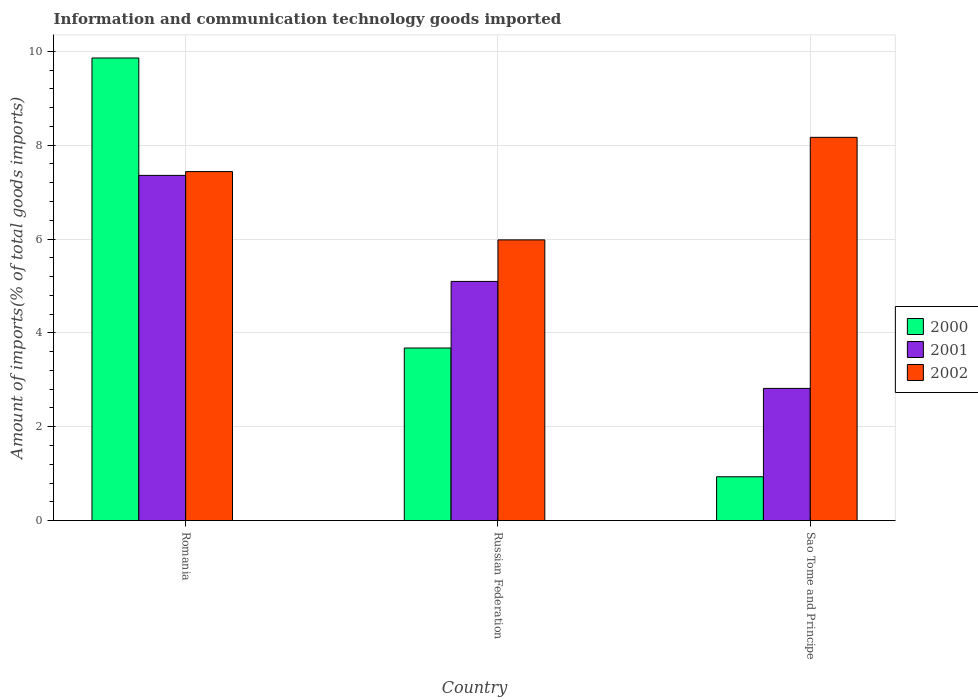How many different coloured bars are there?
Offer a terse response. 3. Are the number of bars per tick equal to the number of legend labels?
Your answer should be compact. Yes. Are the number of bars on each tick of the X-axis equal?
Your response must be concise. Yes. What is the label of the 1st group of bars from the left?
Provide a short and direct response. Romania. What is the amount of goods imported in 2002 in Sao Tome and Principe?
Offer a terse response. 8.17. Across all countries, what is the maximum amount of goods imported in 2000?
Provide a succinct answer. 9.86. Across all countries, what is the minimum amount of goods imported in 2001?
Your response must be concise. 2.82. In which country was the amount of goods imported in 2001 maximum?
Your answer should be compact. Romania. In which country was the amount of goods imported in 2000 minimum?
Give a very brief answer. Sao Tome and Principe. What is the total amount of goods imported in 2002 in the graph?
Offer a terse response. 21.59. What is the difference between the amount of goods imported in 2000 in Romania and that in Russian Federation?
Give a very brief answer. 6.18. What is the difference between the amount of goods imported in 2002 in Sao Tome and Principe and the amount of goods imported in 2000 in Romania?
Give a very brief answer. -1.69. What is the average amount of goods imported in 2000 per country?
Provide a succinct answer. 4.82. What is the difference between the amount of goods imported of/in 2000 and amount of goods imported of/in 2002 in Russian Federation?
Make the answer very short. -2.3. In how many countries, is the amount of goods imported in 2000 greater than 7.6 %?
Offer a terse response. 1. What is the ratio of the amount of goods imported in 2000 in Romania to that in Russian Federation?
Offer a terse response. 2.68. Is the difference between the amount of goods imported in 2000 in Romania and Russian Federation greater than the difference between the amount of goods imported in 2002 in Romania and Russian Federation?
Ensure brevity in your answer.  Yes. What is the difference between the highest and the second highest amount of goods imported in 2001?
Provide a short and direct response. -2.28. What is the difference between the highest and the lowest amount of goods imported in 2002?
Ensure brevity in your answer.  2.19. How many bars are there?
Ensure brevity in your answer.  9. Are all the bars in the graph horizontal?
Offer a terse response. No. How many countries are there in the graph?
Keep it short and to the point. 3. What is the difference between two consecutive major ticks on the Y-axis?
Your answer should be very brief. 2. Are the values on the major ticks of Y-axis written in scientific E-notation?
Make the answer very short. No. Where does the legend appear in the graph?
Ensure brevity in your answer.  Center right. How many legend labels are there?
Ensure brevity in your answer.  3. What is the title of the graph?
Offer a very short reply. Information and communication technology goods imported. Does "1987" appear as one of the legend labels in the graph?
Your response must be concise. No. What is the label or title of the X-axis?
Your answer should be compact. Country. What is the label or title of the Y-axis?
Provide a short and direct response. Amount of imports(% of total goods imports). What is the Amount of imports(% of total goods imports) in 2000 in Romania?
Ensure brevity in your answer.  9.86. What is the Amount of imports(% of total goods imports) in 2001 in Romania?
Your answer should be compact. 7.36. What is the Amount of imports(% of total goods imports) of 2002 in Romania?
Offer a very short reply. 7.44. What is the Amount of imports(% of total goods imports) of 2000 in Russian Federation?
Make the answer very short. 3.68. What is the Amount of imports(% of total goods imports) in 2001 in Russian Federation?
Provide a succinct answer. 5.1. What is the Amount of imports(% of total goods imports) of 2002 in Russian Federation?
Provide a short and direct response. 5.98. What is the Amount of imports(% of total goods imports) in 2000 in Sao Tome and Principe?
Offer a terse response. 0.93. What is the Amount of imports(% of total goods imports) in 2001 in Sao Tome and Principe?
Your response must be concise. 2.82. What is the Amount of imports(% of total goods imports) in 2002 in Sao Tome and Principe?
Your answer should be very brief. 8.17. Across all countries, what is the maximum Amount of imports(% of total goods imports) of 2000?
Offer a very short reply. 9.86. Across all countries, what is the maximum Amount of imports(% of total goods imports) of 2001?
Your answer should be compact. 7.36. Across all countries, what is the maximum Amount of imports(% of total goods imports) in 2002?
Offer a terse response. 8.17. Across all countries, what is the minimum Amount of imports(% of total goods imports) in 2000?
Your answer should be compact. 0.93. Across all countries, what is the minimum Amount of imports(% of total goods imports) of 2001?
Your answer should be very brief. 2.82. Across all countries, what is the minimum Amount of imports(% of total goods imports) in 2002?
Give a very brief answer. 5.98. What is the total Amount of imports(% of total goods imports) in 2000 in the graph?
Provide a short and direct response. 14.47. What is the total Amount of imports(% of total goods imports) in 2001 in the graph?
Ensure brevity in your answer.  15.27. What is the total Amount of imports(% of total goods imports) of 2002 in the graph?
Your response must be concise. 21.59. What is the difference between the Amount of imports(% of total goods imports) in 2000 in Romania and that in Russian Federation?
Ensure brevity in your answer.  6.18. What is the difference between the Amount of imports(% of total goods imports) in 2001 in Romania and that in Russian Federation?
Your response must be concise. 2.26. What is the difference between the Amount of imports(% of total goods imports) of 2002 in Romania and that in Russian Federation?
Keep it short and to the point. 1.46. What is the difference between the Amount of imports(% of total goods imports) in 2000 in Romania and that in Sao Tome and Principe?
Provide a succinct answer. 8.92. What is the difference between the Amount of imports(% of total goods imports) in 2001 in Romania and that in Sao Tome and Principe?
Give a very brief answer. 4.54. What is the difference between the Amount of imports(% of total goods imports) of 2002 in Romania and that in Sao Tome and Principe?
Make the answer very short. -0.73. What is the difference between the Amount of imports(% of total goods imports) in 2000 in Russian Federation and that in Sao Tome and Principe?
Give a very brief answer. 2.74. What is the difference between the Amount of imports(% of total goods imports) of 2001 in Russian Federation and that in Sao Tome and Principe?
Make the answer very short. 2.28. What is the difference between the Amount of imports(% of total goods imports) in 2002 in Russian Federation and that in Sao Tome and Principe?
Offer a terse response. -2.19. What is the difference between the Amount of imports(% of total goods imports) in 2000 in Romania and the Amount of imports(% of total goods imports) in 2001 in Russian Federation?
Provide a short and direct response. 4.76. What is the difference between the Amount of imports(% of total goods imports) of 2000 in Romania and the Amount of imports(% of total goods imports) of 2002 in Russian Federation?
Your response must be concise. 3.88. What is the difference between the Amount of imports(% of total goods imports) in 2001 in Romania and the Amount of imports(% of total goods imports) in 2002 in Russian Federation?
Your answer should be very brief. 1.37. What is the difference between the Amount of imports(% of total goods imports) of 2000 in Romania and the Amount of imports(% of total goods imports) of 2001 in Sao Tome and Principe?
Your response must be concise. 7.04. What is the difference between the Amount of imports(% of total goods imports) of 2000 in Romania and the Amount of imports(% of total goods imports) of 2002 in Sao Tome and Principe?
Ensure brevity in your answer.  1.69. What is the difference between the Amount of imports(% of total goods imports) in 2001 in Romania and the Amount of imports(% of total goods imports) in 2002 in Sao Tome and Principe?
Ensure brevity in your answer.  -0.81. What is the difference between the Amount of imports(% of total goods imports) in 2000 in Russian Federation and the Amount of imports(% of total goods imports) in 2001 in Sao Tome and Principe?
Provide a short and direct response. 0.86. What is the difference between the Amount of imports(% of total goods imports) of 2000 in Russian Federation and the Amount of imports(% of total goods imports) of 2002 in Sao Tome and Principe?
Keep it short and to the point. -4.49. What is the difference between the Amount of imports(% of total goods imports) in 2001 in Russian Federation and the Amount of imports(% of total goods imports) in 2002 in Sao Tome and Principe?
Your response must be concise. -3.07. What is the average Amount of imports(% of total goods imports) in 2000 per country?
Keep it short and to the point. 4.82. What is the average Amount of imports(% of total goods imports) in 2001 per country?
Make the answer very short. 5.09. What is the average Amount of imports(% of total goods imports) of 2002 per country?
Your answer should be very brief. 7.2. What is the difference between the Amount of imports(% of total goods imports) in 2000 and Amount of imports(% of total goods imports) in 2001 in Romania?
Your answer should be very brief. 2.5. What is the difference between the Amount of imports(% of total goods imports) in 2000 and Amount of imports(% of total goods imports) in 2002 in Romania?
Offer a terse response. 2.42. What is the difference between the Amount of imports(% of total goods imports) in 2001 and Amount of imports(% of total goods imports) in 2002 in Romania?
Provide a short and direct response. -0.08. What is the difference between the Amount of imports(% of total goods imports) of 2000 and Amount of imports(% of total goods imports) of 2001 in Russian Federation?
Ensure brevity in your answer.  -1.42. What is the difference between the Amount of imports(% of total goods imports) of 2000 and Amount of imports(% of total goods imports) of 2002 in Russian Federation?
Your answer should be very brief. -2.3. What is the difference between the Amount of imports(% of total goods imports) in 2001 and Amount of imports(% of total goods imports) in 2002 in Russian Federation?
Offer a very short reply. -0.89. What is the difference between the Amount of imports(% of total goods imports) in 2000 and Amount of imports(% of total goods imports) in 2001 in Sao Tome and Principe?
Your answer should be very brief. -1.88. What is the difference between the Amount of imports(% of total goods imports) of 2000 and Amount of imports(% of total goods imports) of 2002 in Sao Tome and Principe?
Provide a short and direct response. -7.23. What is the difference between the Amount of imports(% of total goods imports) in 2001 and Amount of imports(% of total goods imports) in 2002 in Sao Tome and Principe?
Your answer should be compact. -5.35. What is the ratio of the Amount of imports(% of total goods imports) in 2000 in Romania to that in Russian Federation?
Provide a short and direct response. 2.68. What is the ratio of the Amount of imports(% of total goods imports) of 2001 in Romania to that in Russian Federation?
Your response must be concise. 1.44. What is the ratio of the Amount of imports(% of total goods imports) in 2002 in Romania to that in Russian Federation?
Give a very brief answer. 1.24. What is the ratio of the Amount of imports(% of total goods imports) in 2000 in Romania to that in Sao Tome and Principe?
Provide a succinct answer. 10.56. What is the ratio of the Amount of imports(% of total goods imports) of 2001 in Romania to that in Sao Tome and Principe?
Offer a very short reply. 2.61. What is the ratio of the Amount of imports(% of total goods imports) of 2002 in Romania to that in Sao Tome and Principe?
Your answer should be compact. 0.91. What is the ratio of the Amount of imports(% of total goods imports) of 2000 in Russian Federation to that in Sao Tome and Principe?
Offer a terse response. 3.94. What is the ratio of the Amount of imports(% of total goods imports) in 2001 in Russian Federation to that in Sao Tome and Principe?
Your response must be concise. 1.81. What is the ratio of the Amount of imports(% of total goods imports) of 2002 in Russian Federation to that in Sao Tome and Principe?
Make the answer very short. 0.73. What is the difference between the highest and the second highest Amount of imports(% of total goods imports) of 2000?
Provide a succinct answer. 6.18. What is the difference between the highest and the second highest Amount of imports(% of total goods imports) of 2001?
Provide a short and direct response. 2.26. What is the difference between the highest and the second highest Amount of imports(% of total goods imports) of 2002?
Provide a short and direct response. 0.73. What is the difference between the highest and the lowest Amount of imports(% of total goods imports) of 2000?
Your answer should be compact. 8.92. What is the difference between the highest and the lowest Amount of imports(% of total goods imports) in 2001?
Keep it short and to the point. 4.54. What is the difference between the highest and the lowest Amount of imports(% of total goods imports) of 2002?
Offer a very short reply. 2.19. 